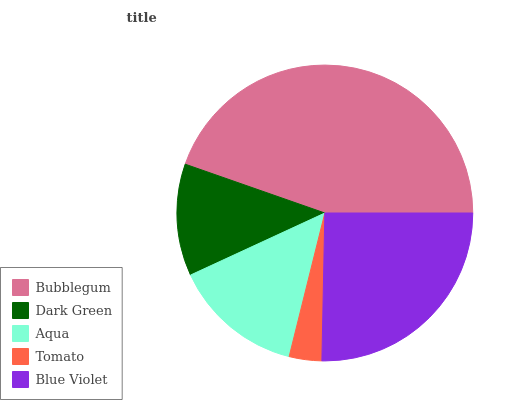Is Tomato the minimum?
Answer yes or no. Yes. Is Bubblegum the maximum?
Answer yes or no. Yes. Is Dark Green the minimum?
Answer yes or no. No. Is Dark Green the maximum?
Answer yes or no. No. Is Bubblegum greater than Dark Green?
Answer yes or no. Yes. Is Dark Green less than Bubblegum?
Answer yes or no. Yes. Is Dark Green greater than Bubblegum?
Answer yes or no. No. Is Bubblegum less than Dark Green?
Answer yes or no. No. Is Aqua the high median?
Answer yes or no. Yes. Is Aqua the low median?
Answer yes or no. Yes. Is Tomato the high median?
Answer yes or no. No. Is Blue Violet the low median?
Answer yes or no. No. 